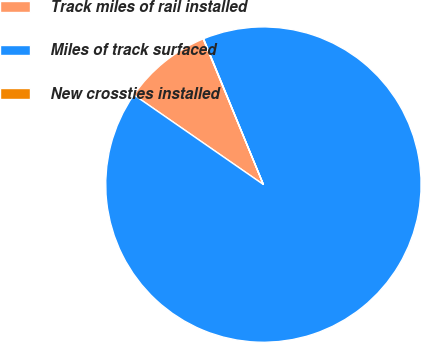Convert chart to OTSL. <chart><loc_0><loc_0><loc_500><loc_500><pie_chart><fcel>Track miles of rail installed<fcel>Miles of track surfaced<fcel>New crossties installed<nl><fcel>9.12%<fcel>90.84%<fcel>0.04%<nl></chart> 